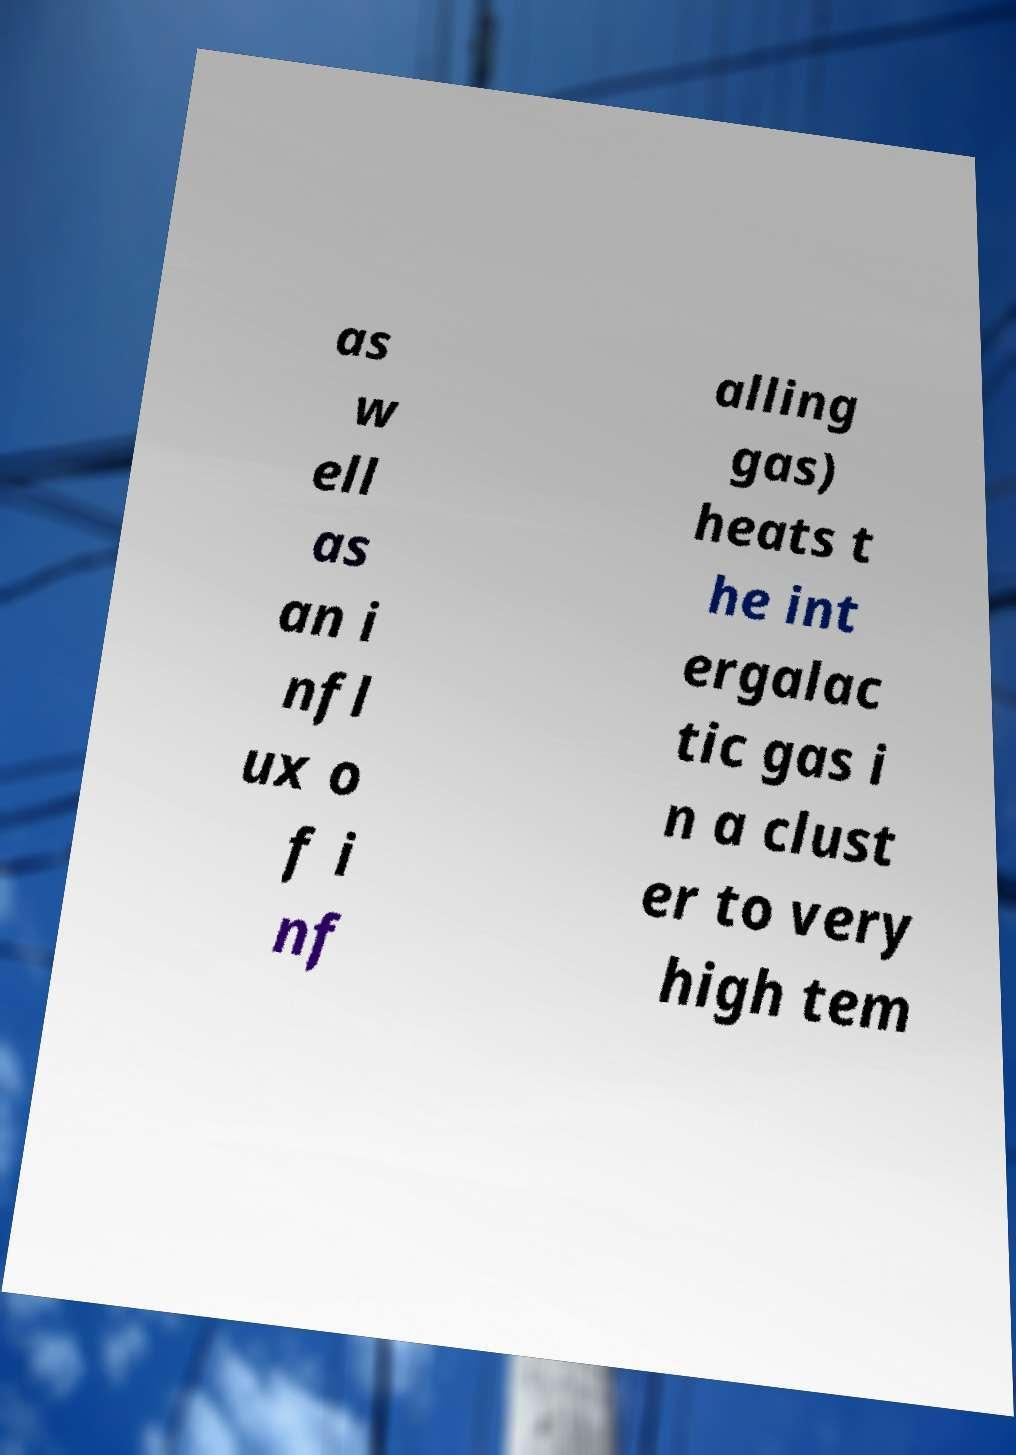For documentation purposes, I need the text within this image transcribed. Could you provide that? as w ell as an i nfl ux o f i nf alling gas) heats t he int ergalac tic gas i n a clust er to very high tem 